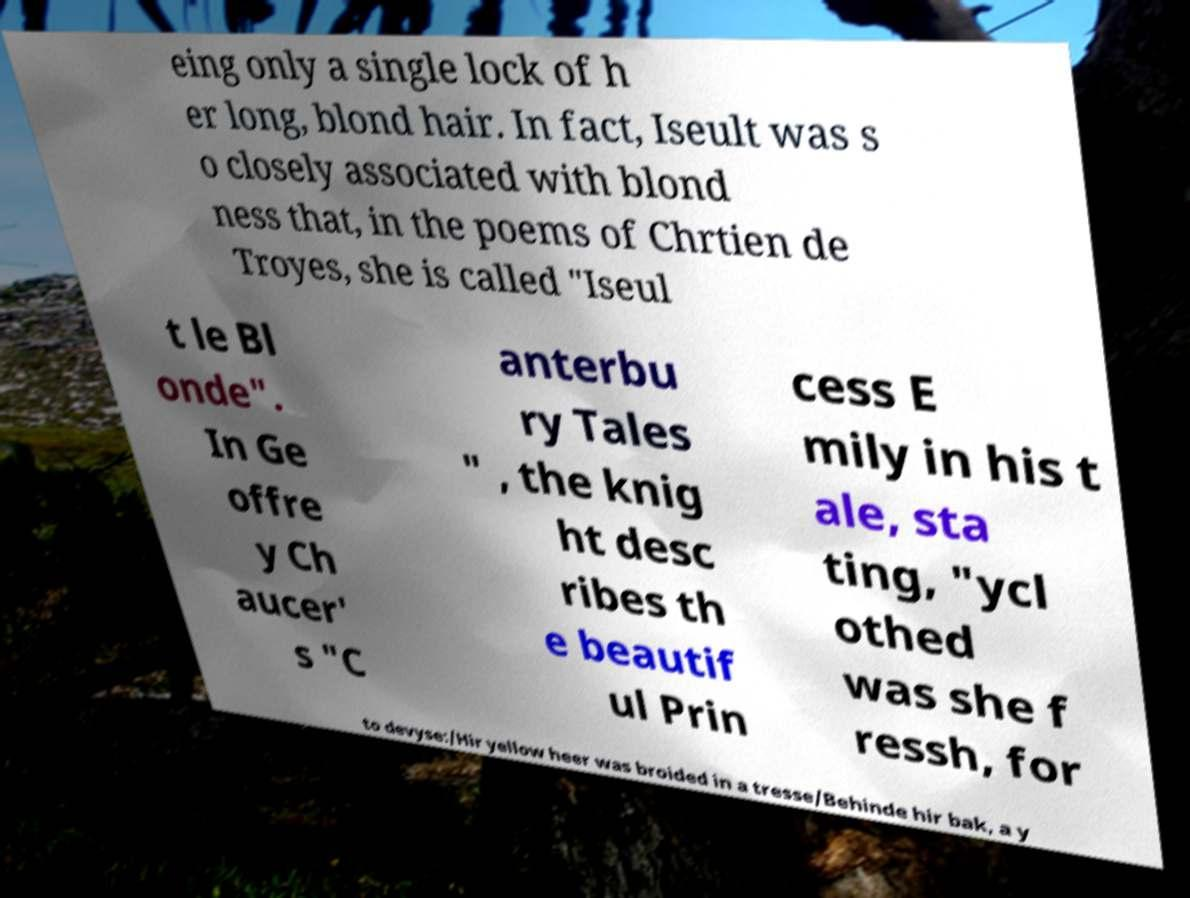What messages or text are displayed in this image? I need them in a readable, typed format. eing only a single lock of h er long, blond hair. In fact, Iseult was s o closely associated with blond ness that, in the poems of Chrtien de Troyes, she is called "Iseul t le Bl onde". In Ge offre y Ch aucer' s "C anterbu ry Tales " , the knig ht desc ribes th e beautif ul Prin cess E mily in his t ale, sta ting, "ycl othed was she f ressh, for to devyse:/Hir yellow heer was broided in a tresse/Behinde hir bak, a y 